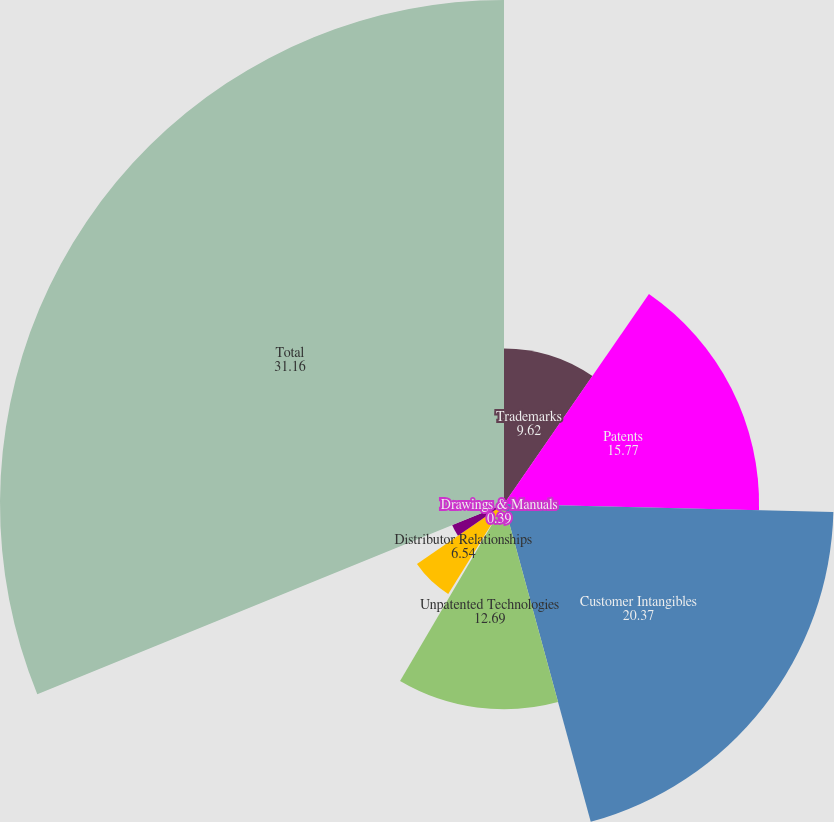Convert chart to OTSL. <chart><loc_0><loc_0><loc_500><loc_500><pie_chart><fcel>Trademarks<fcel>Patents<fcel>Customer Intangibles<fcel>Unpatented Technologies<fcel>Drawings & Manuals<fcel>Distributor Relationships<fcel>Other<fcel>Total<nl><fcel>9.62%<fcel>15.77%<fcel>20.37%<fcel>12.69%<fcel>0.39%<fcel>6.54%<fcel>3.46%<fcel>31.16%<nl></chart> 